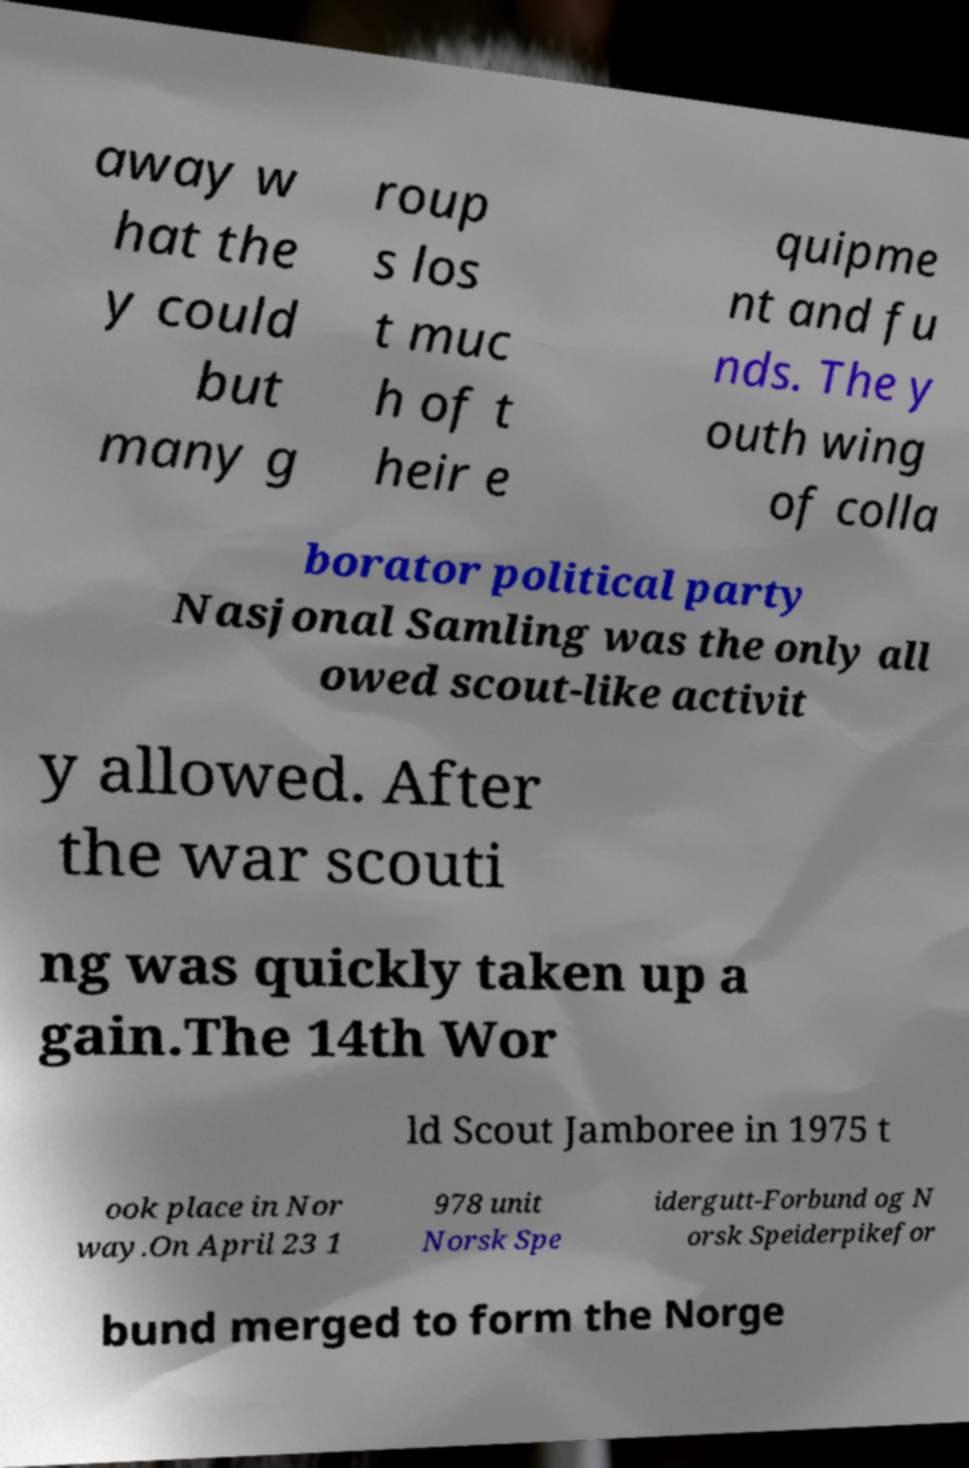For documentation purposes, I need the text within this image transcribed. Could you provide that? away w hat the y could but many g roup s los t muc h of t heir e quipme nt and fu nds. The y outh wing of colla borator political party Nasjonal Samling was the only all owed scout-like activit y allowed. After the war scouti ng was quickly taken up a gain.The 14th Wor ld Scout Jamboree in 1975 t ook place in Nor way.On April 23 1 978 unit Norsk Spe idergutt-Forbund og N orsk Speiderpikefor bund merged to form the Norge 